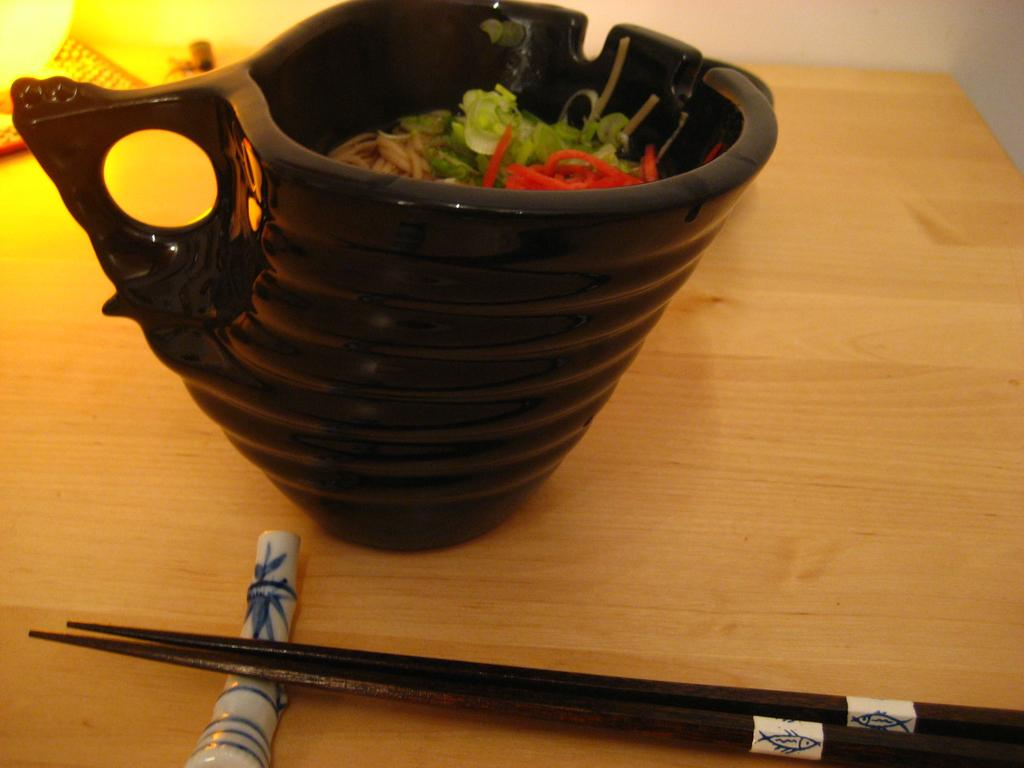What is located on the table in the image? There is a bowl and sticks on the table in the image. What is the purpose of the sticks in the image? The purpose of the sticks is not explicitly stated, but they are likely used for stirring or serving the contents of the bowl. What is the main subject of the image? The main subject of the image is the bowl. What type of root can be seen growing from the bowl in the image? There is no root growing from the bowl in the image. What is the smell of the pigs in the image? There are no pigs present in the image, so it is not possible to determine their smell. 